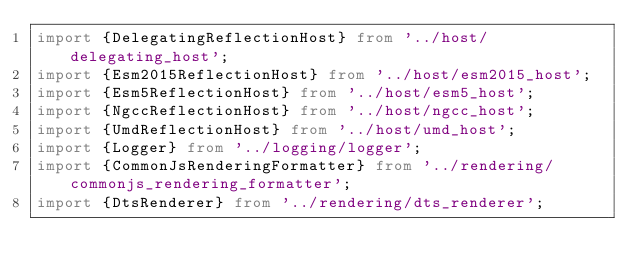Convert code to text. <code><loc_0><loc_0><loc_500><loc_500><_TypeScript_>import {DelegatingReflectionHost} from '../host/delegating_host';
import {Esm2015ReflectionHost} from '../host/esm2015_host';
import {Esm5ReflectionHost} from '../host/esm5_host';
import {NgccReflectionHost} from '../host/ngcc_host';
import {UmdReflectionHost} from '../host/umd_host';
import {Logger} from '../logging/logger';
import {CommonJsRenderingFormatter} from '../rendering/commonjs_rendering_formatter';
import {DtsRenderer} from '../rendering/dts_renderer';</code> 